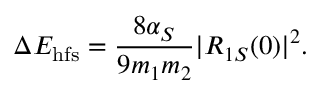<formula> <loc_0><loc_0><loc_500><loc_500>\Delta E _ { h f s } = \frac { 8 \alpha _ { S } } { 9 m _ { 1 } m _ { 2 } } | R _ { 1 S } ( 0 ) | ^ { 2 } .</formula> 